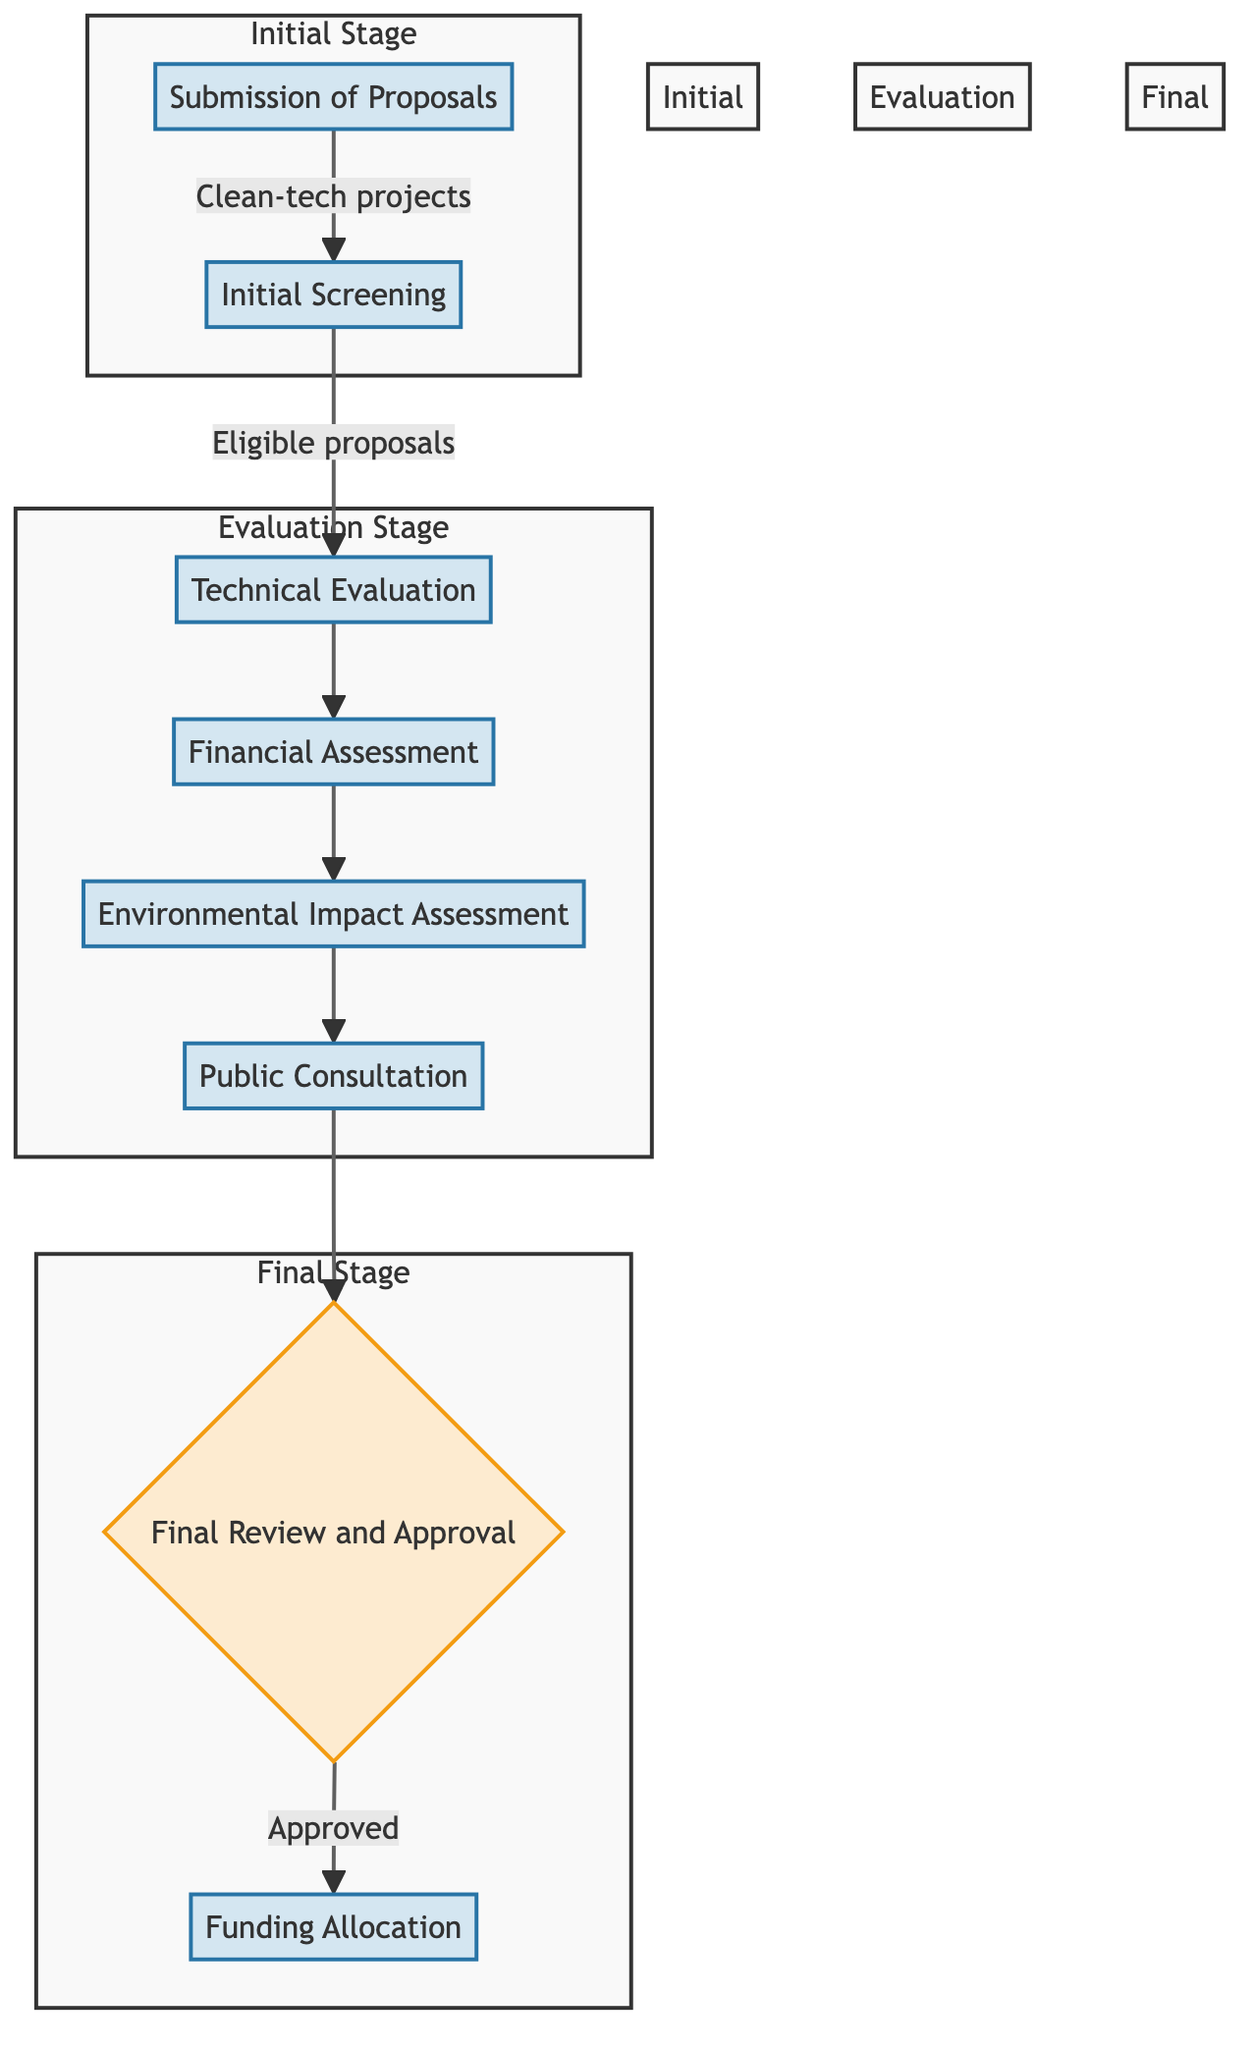What is the first step in the proposal evaluation process? The first step is the "Submission of Proposals," where clean-tech project proposals are submitted to the Ministry of Finance.
Answer: Submission of Proposals Which department is involved in the initial screening? The departments involved in the initial screening are the "Administrative Office" and the "Legal Department," as indicated in the diagram.
Answer: Administrative Office, Legal Department How many stages are there in the evaluation process? There are three stages in the evaluation process: Initial Stage, Evaluation Stage, and Final Stage, each marked with distinct groupings in the flowchart.
Answer: Three What follows the Financial Assessment step? After the Financial Assessment step, the next step is the "Environmental Impact Assessment," as shown by the directional flow from one step to the next in the diagram.
Answer: Environmental Impact Assessment Which step involves public opinion gathering? The step that involves gathering public opinion is the "Public Consultation," where stakeholder consultations are held to gauge social acceptance.
Answer: Public Consultation What is the role of the Ministerial Board? The role of the Ministerial Board is to conduct the "Final Review and Approval" of the proposals before any funding is allocated.
Answer: Final Review and Approval What happens to approved projects? Approved projects move to the "Funding Allocation," where they receive funds from the clean-tech budget as indicated in the final step of the flowchart.
Answer: Funding Allocation Which department is involved at the funding allocation stage? The departments involved at the funding allocation stage are the "Finance Ministry" and the "Treasury Office," as outlined in the diagram.
Answer: Finance Ministry, Treasury Office What step must a proposal pass through before public consultation? A proposal must pass through the "Environmental Impact Assessment" before it reaches the "Public Consultation" stage according to the flow in the diagram.
Answer: Environmental Impact Assessment 